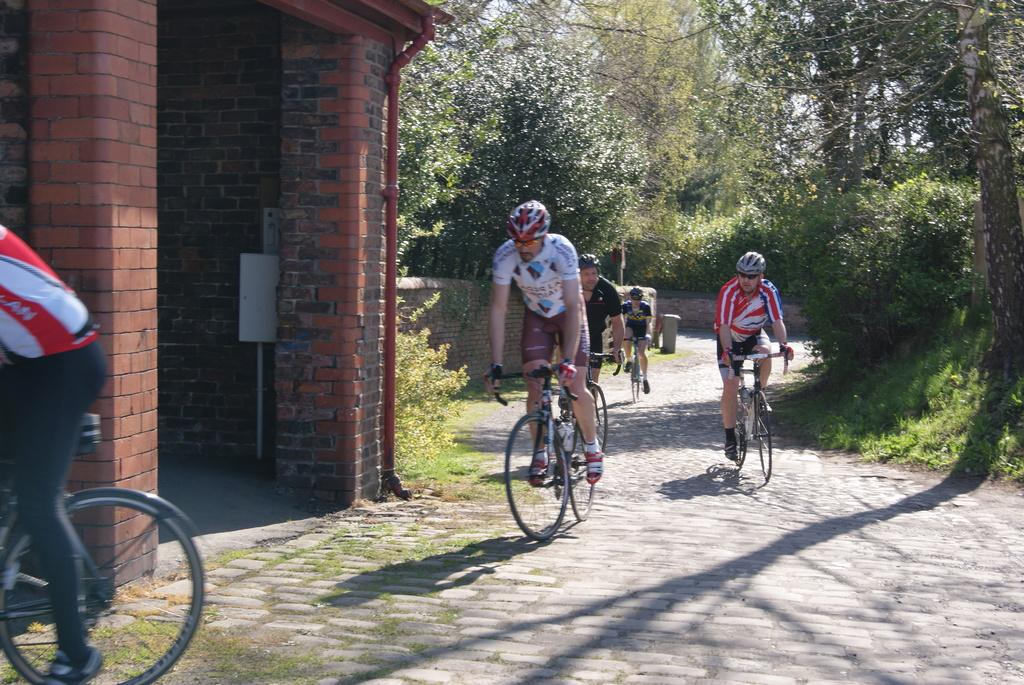How many boys are in the image? There are boys in the image, but the exact number is not specified. What are the boys doing in the image? The boys are cycling on the road in the image. What safety precaution are the boys taking while cycling? The boys are wearing helmets in the image. What type of natural environment can be seen in the image? There are trees visible in the image. What structure is located on the left side of the image? There appears to be a building on the left side of the image. What type of knife is the boy using to cut the heat in the image? There is no knife or heat present in the image; the boys are cycling on the road and wearing helmets. How does the sand affect the boys' cycling in the image? There is no sand present in the image; the boys are cycling on a road with trees and a building visible. 